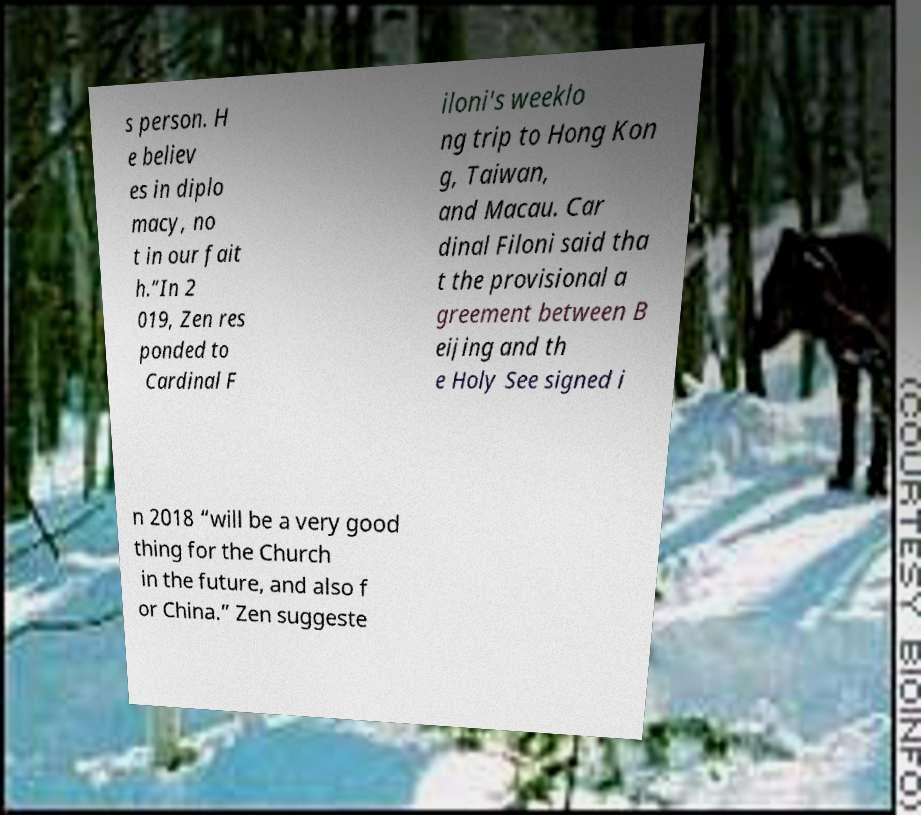Could you extract and type out the text from this image? s person. H e believ es in diplo macy, no t in our fait h.”In 2 019, Zen res ponded to Cardinal F iloni's weeklo ng trip to Hong Kon g, Taiwan, and Macau. Car dinal Filoni said tha t the provisional a greement between B eijing and th e Holy See signed i n 2018 “will be a very good thing for the Church in the future, and also f or China.” Zen suggeste 